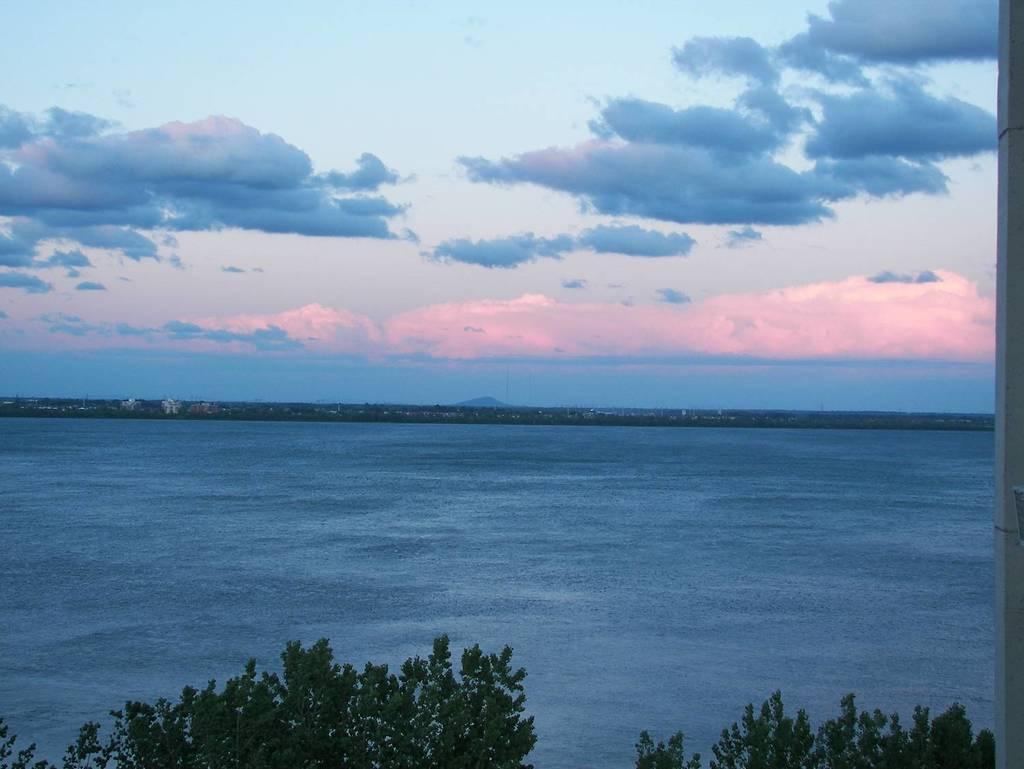In one or two sentences, can you explain what this image depicts? In this image, I can see the trees with branches and leaves. Here is the water flowing. These are the clouds in the sky. In the background, I can see the buildings. 